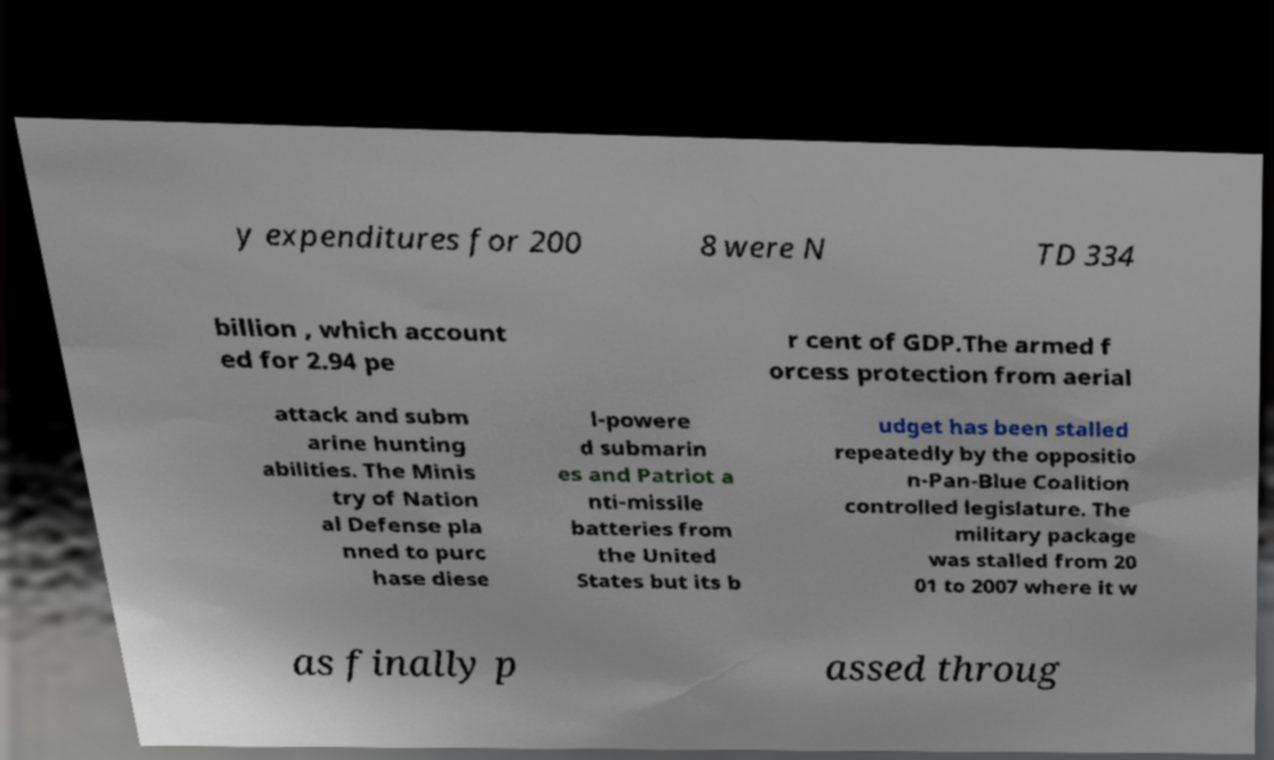For documentation purposes, I need the text within this image transcribed. Could you provide that? y expenditures for 200 8 were N TD 334 billion , which account ed for 2.94 pe r cent of GDP.The armed f orcess protection from aerial attack and subm arine hunting abilities. The Minis try of Nation al Defense pla nned to purc hase diese l-powere d submarin es and Patriot a nti-missile batteries from the United States but its b udget has been stalled repeatedly by the oppositio n-Pan-Blue Coalition controlled legislature. The military package was stalled from 20 01 to 2007 where it w as finally p assed throug 